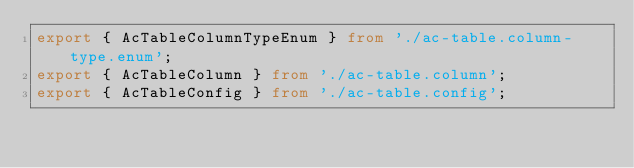Convert code to text. <code><loc_0><loc_0><loc_500><loc_500><_TypeScript_>export { AcTableColumnTypeEnum } from './ac-table.column-type.enum';
export { AcTableColumn } from './ac-table.column';
export { AcTableConfig } from './ac-table.config';</code> 